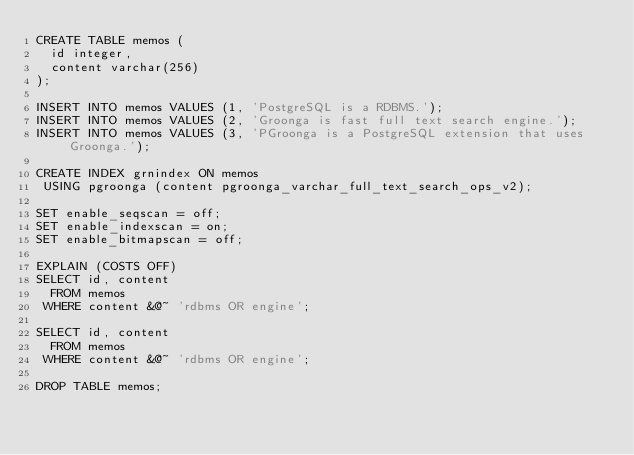Convert code to text. <code><loc_0><loc_0><loc_500><loc_500><_SQL_>CREATE TABLE memos (
  id integer,
  content varchar(256)
);

INSERT INTO memos VALUES (1, 'PostgreSQL is a RDBMS.');
INSERT INTO memos VALUES (2, 'Groonga is fast full text search engine.');
INSERT INTO memos VALUES (3, 'PGroonga is a PostgreSQL extension that uses Groonga.');

CREATE INDEX grnindex ON memos
 USING pgroonga (content pgroonga_varchar_full_text_search_ops_v2);

SET enable_seqscan = off;
SET enable_indexscan = on;
SET enable_bitmapscan = off;

EXPLAIN (COSTS OFF)
SELECT id, content
  FROM memos
 WHERE content &@~ 'rdbms OR engine';

SELECT id, content
  FROM memos
 WHERE content &@~ 'rdbms OR engine';

DROP TABLE memos;
</code> 